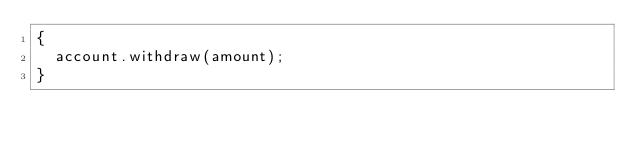<code> <loc_0><loc_0><loc_500><loc_500><_C++_>{
	account.withdraw(amount);
}

</code> 